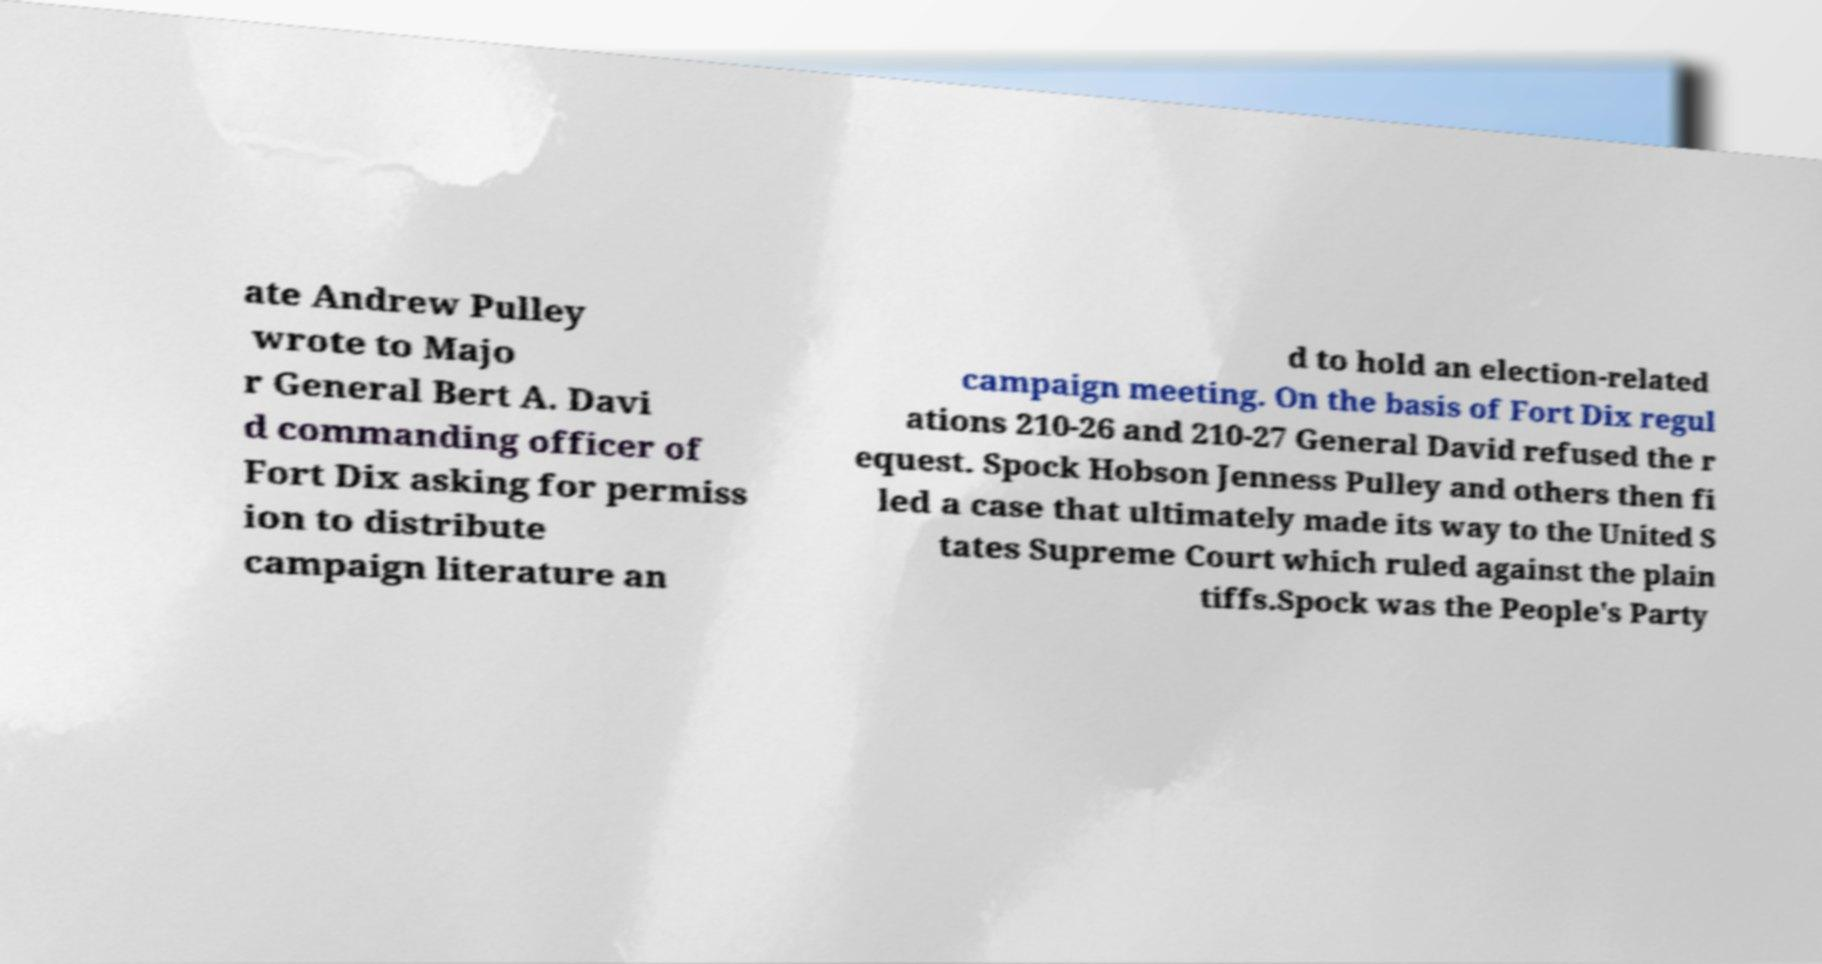Can you read and provide the text displayed in the image?This photo seems to have some interesting text. Can you extract and type it out for me? ate Andrew Pulley wrote to Majo r General Bert A. Davi d commanding officer of Fort Dix asking for permiss ion to distribute campaign literature an d to hold an election-related campaign meeting. On the basis of Fort Dix regul ations 210-26 and 210-27 General David refused the r equest. Spock Hobson Jenness Pulley and others then fi led a case that ultimately made its way to the United S tates Supreme Court which ruled against the plain tiffs.Spock was the People's Party 